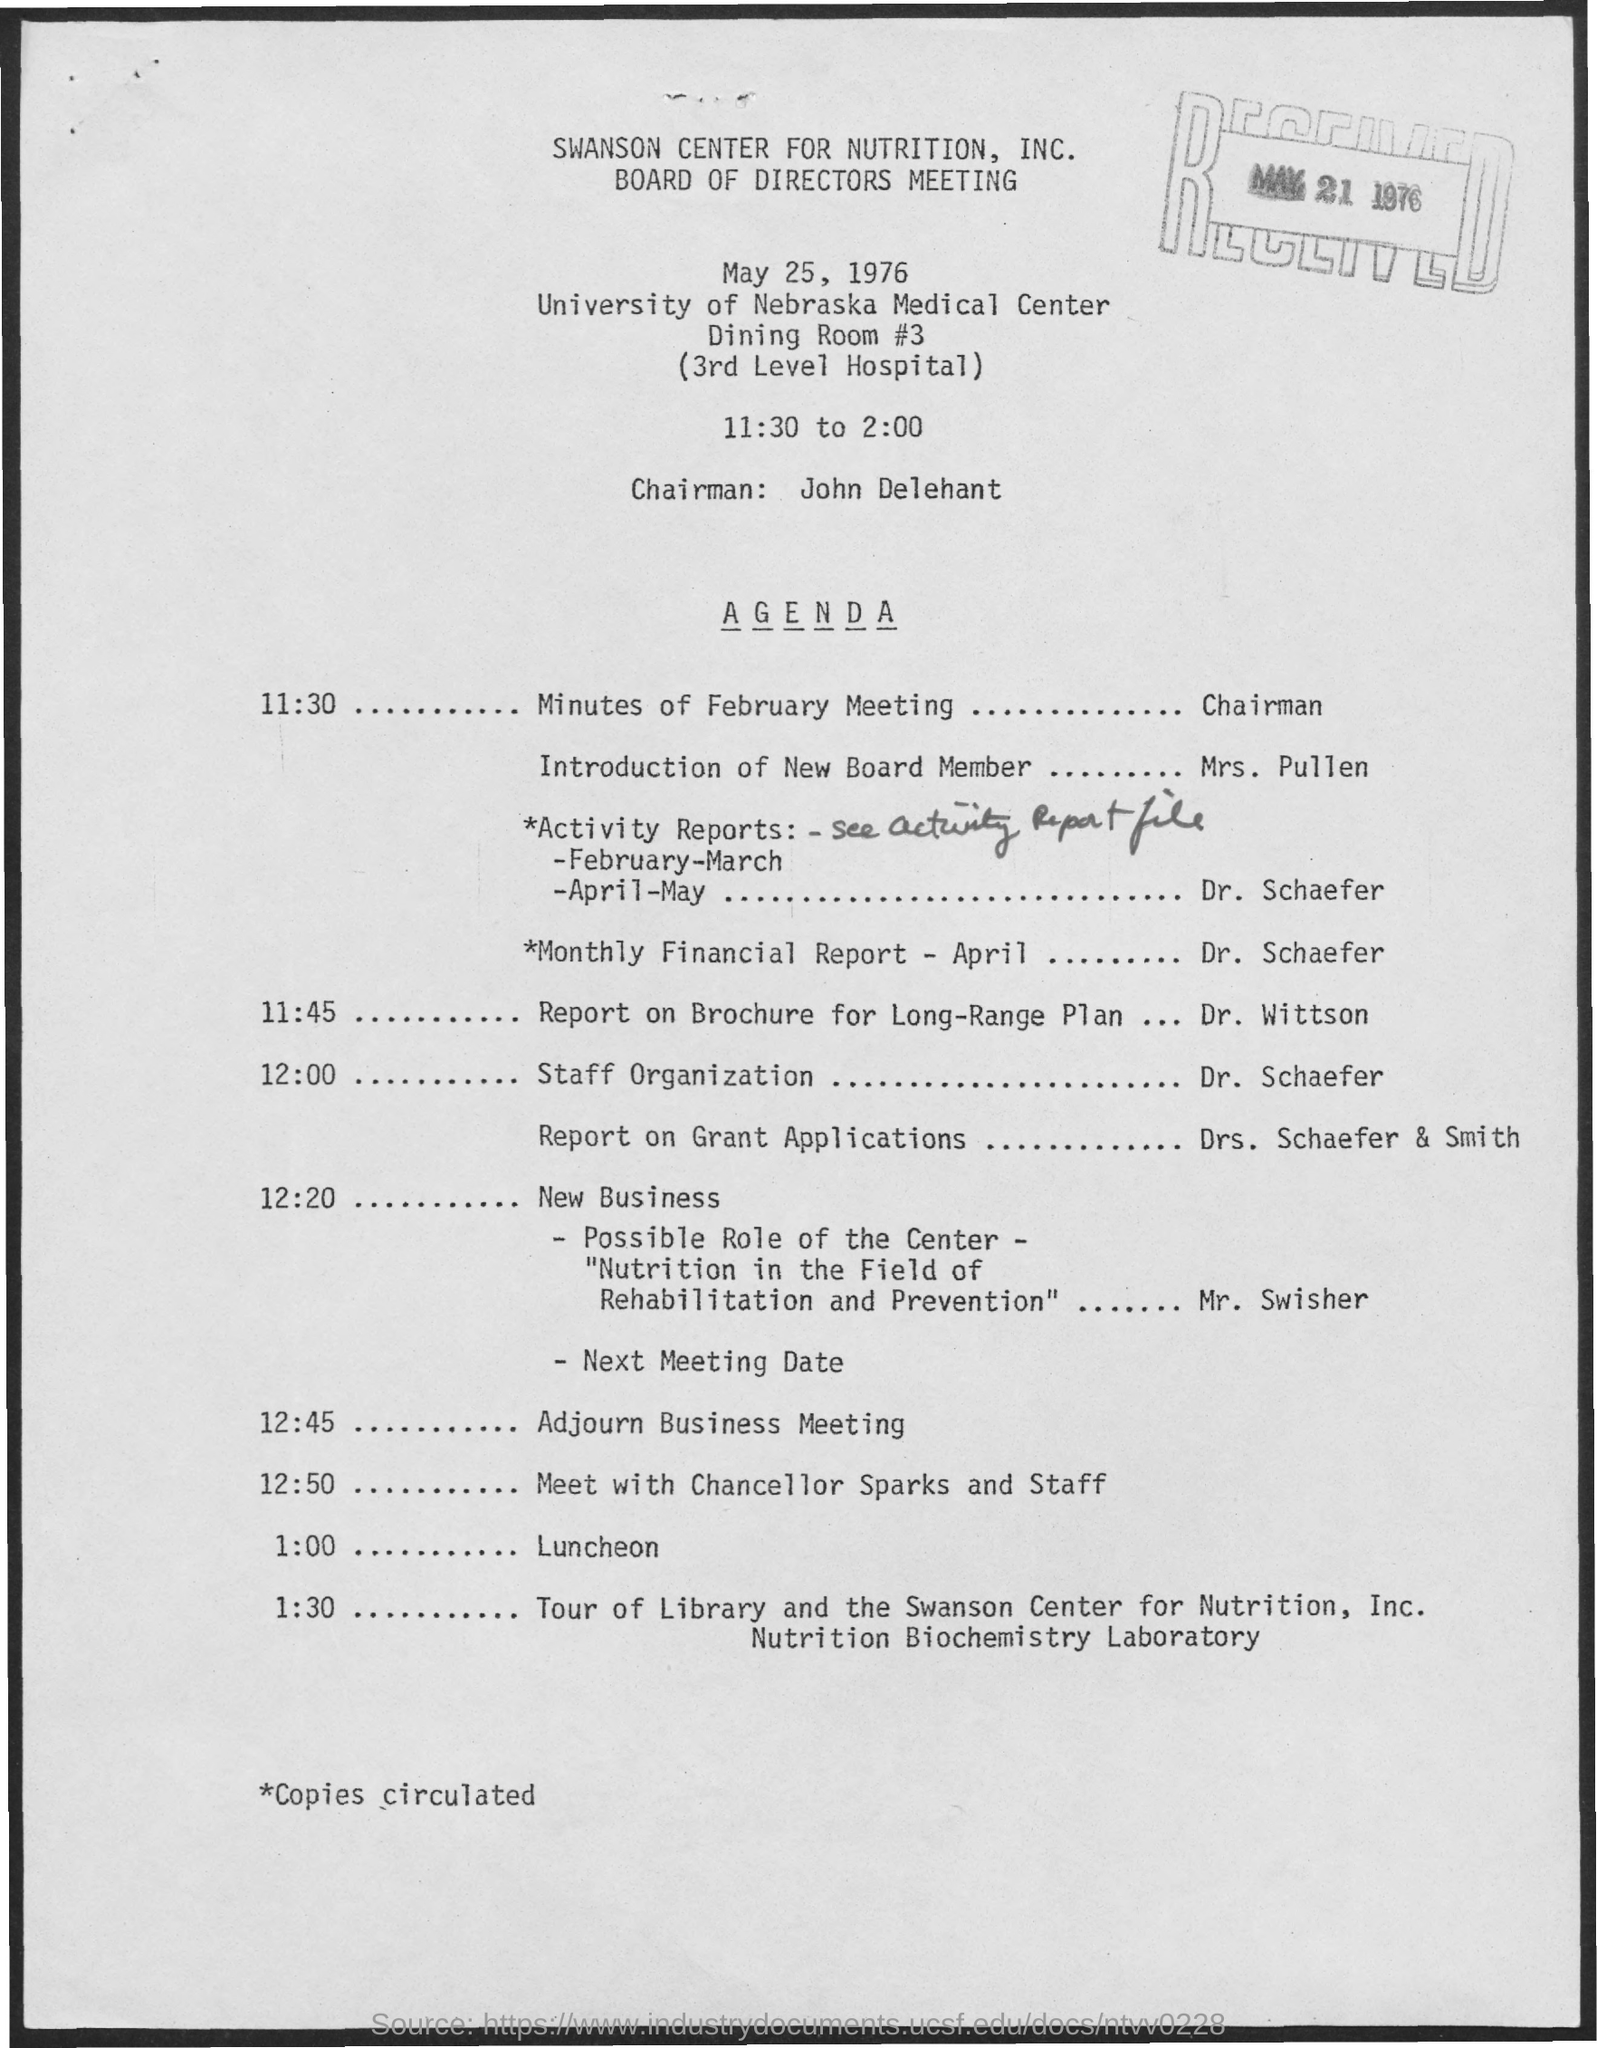Draw attention to some important aspects in this diagram. The chairman's name is John Delehant. The name of the meeting is a Board of Directors meeting. The date mentioned in the given page is May 25, 1976. The received date mentioned is May 21, 1976. What is the time mentioned as 11:30 converted to 2:00? 